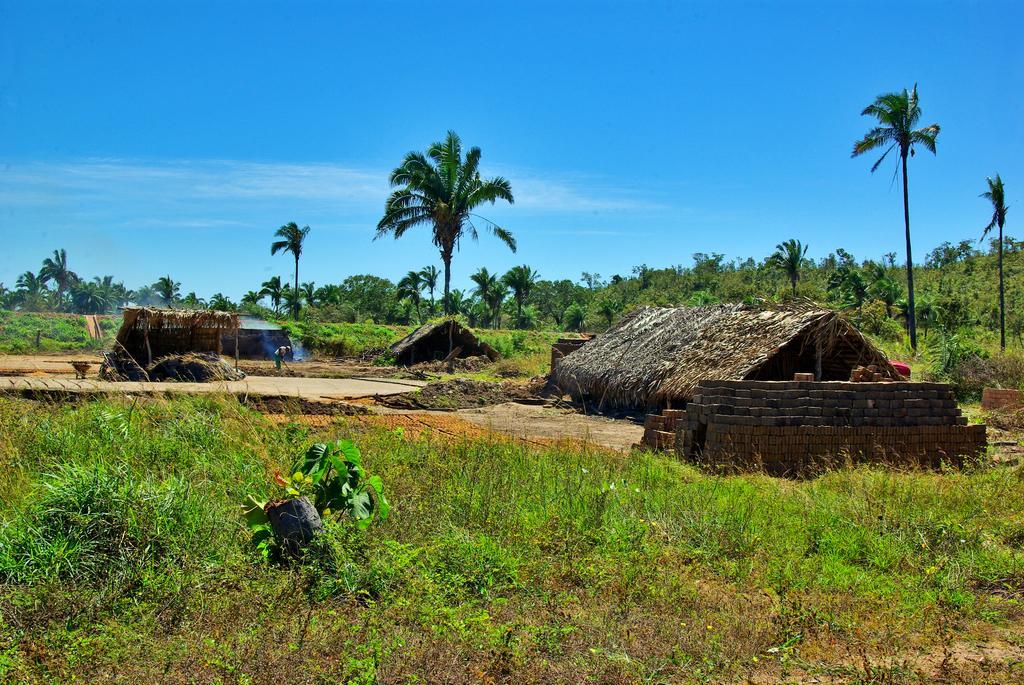Please provide a concise description of this image. This picture is taken from outside of the city. In this image, on the right side, we can see a hut, bricks, trees. On the left side, we can also see a grass and a person. In the middle of the image, we can see a hurt, trees. In the background, we can see some trees, plants. At the top, we can see a sky which is blue color, at the bottom, we can see a grass and few plants. 